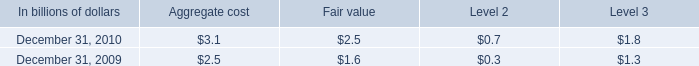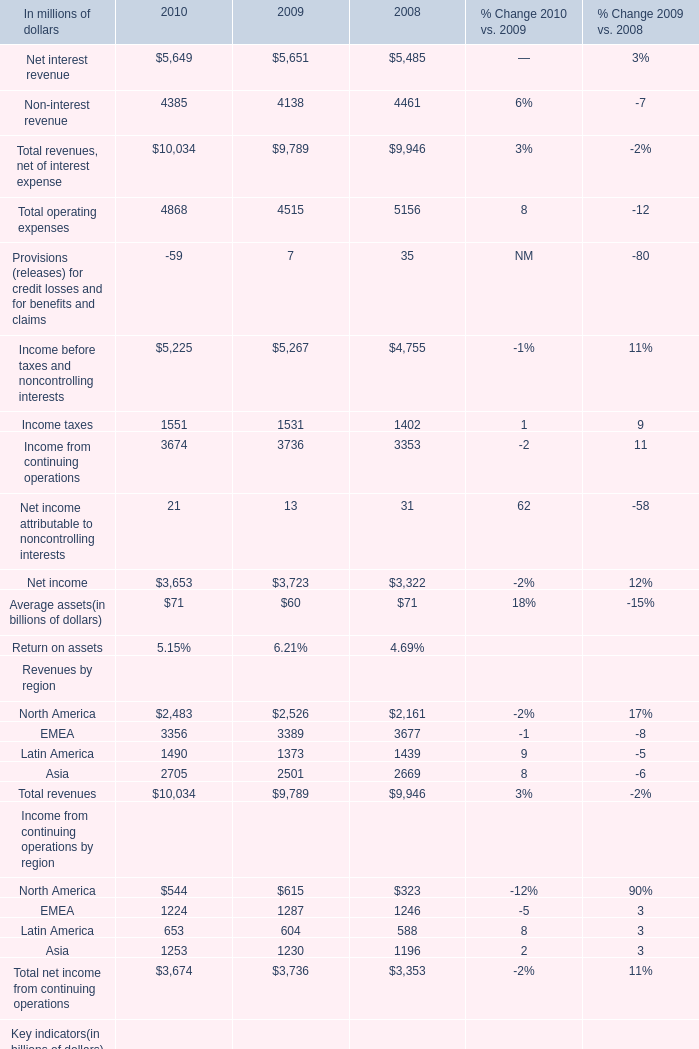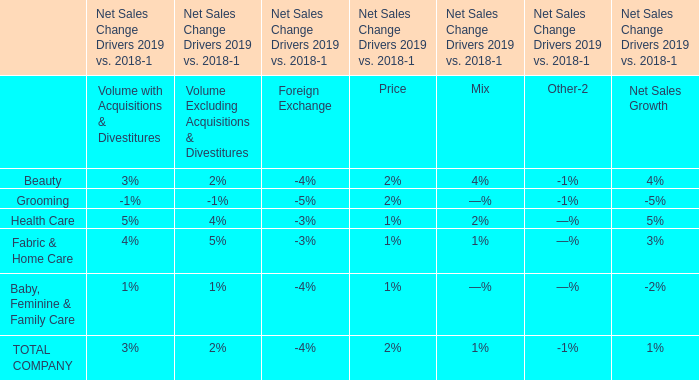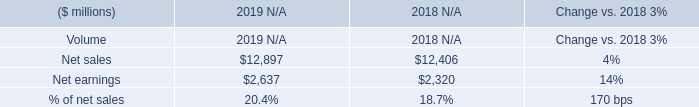What is the sum of Net sales of 2019 N/A, Net income of 2009, and Total operating expenses of 2008 ? 
Computations: ((12897.0 + 3723.0) + 5156.0)
Answer: 21776.0. 